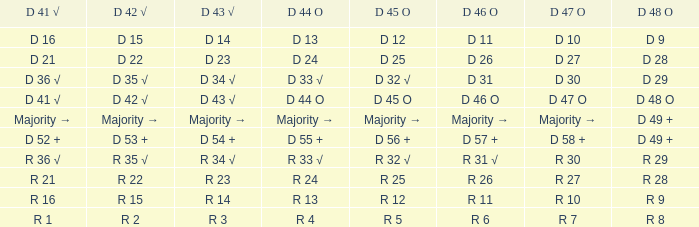Identify the d 47 o along with d 48 o for r 9. R 10. 